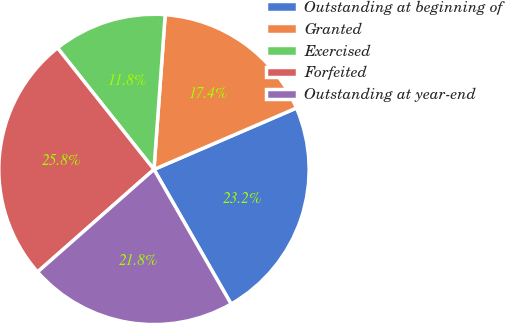<chart> <loc_0><loc_0><loc_500><loc_500><pie_chart><fcel>Outstanding at beginning of<fcel>Granted<fcel>Exercised<fcel>Forfeited<fcel>Outstanding at year-end<nl><fcel>23.19%<fcel>17.37%<fcel>11.83%<fcel>25.81%<fcel>21.79%<nl></chart> 